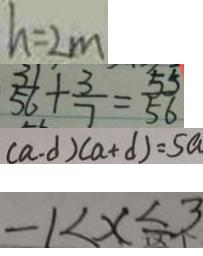<formula> <loc_0><loc_0><loc_500><loc_500>h = 2 m 
 \frac { 3 1 } { 5 6 } + \frac { 3 } { 7 } = \frac { 5 5 } { 5 6 } 
 ( a - d ) ( a + d ) = 5 a 
 - 1 < x \leq 3</formula> 